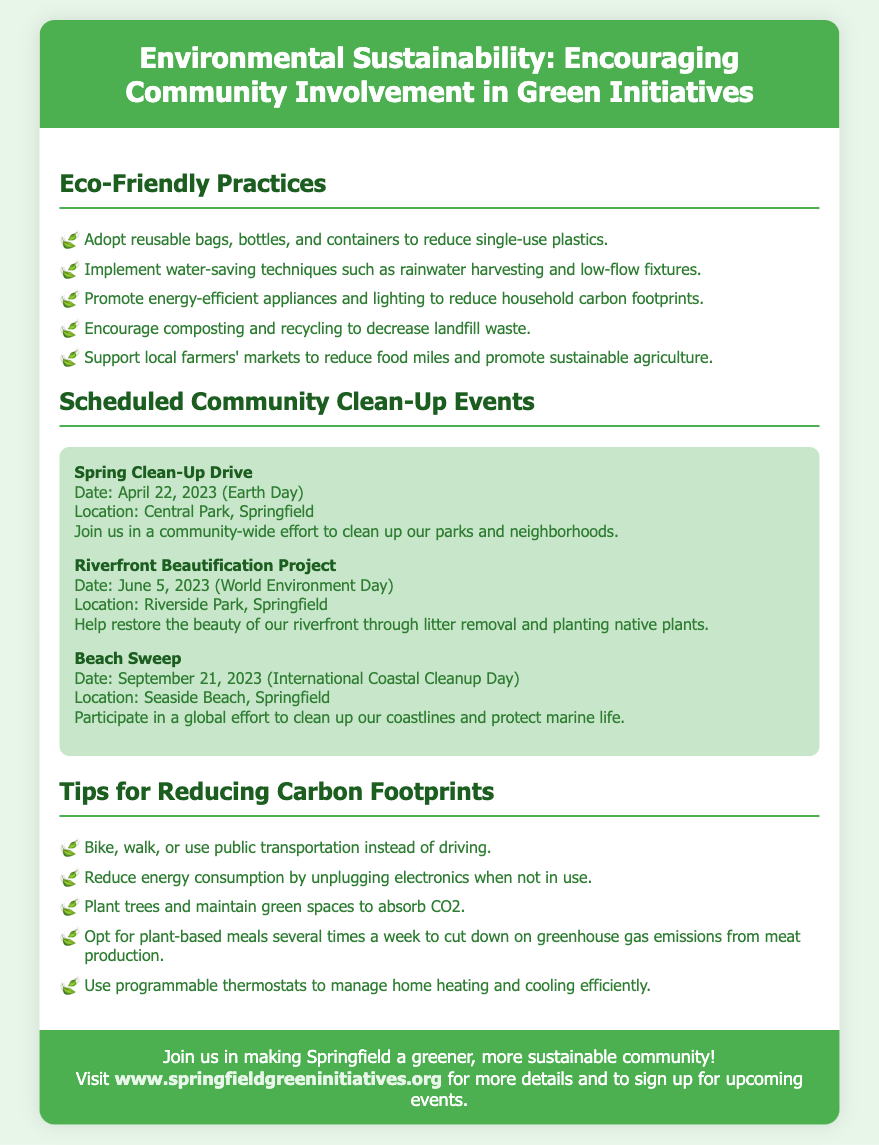What is the title of the poster? The title is prominently displayed at the top of the poster and describes the theme of the document.
Answer: Environmental Sustainability: Encouraging Community Involvement in Green Initiatives What is one eco-friendly practice mentioned in the poster? The poster lists several eco-friendly practices, each as a bullet point under the relevant section.
Answer: Adopt reusable bags, bottles, and containers to reduce single-use plastics When is the Spring Clean-Up Drive scheduled? The date for the Spring Clean-Up Drive is indicated in the events section of the poster.
Answer: April 22, 2023 Where is the Riverfront Beautification Project taking place? The location for the Riverfront Beautification Project is provided in the event details.
Answer: Riverside Park, Springfield What is one tip for reducing carbon footprints? The poster includes tips in a dedicated section, outlining various actions individuals can take.
Answer: Bike, walk, or use public transportation instead of driving How many scheduled community clean-up events are listed in the poster? The poster includes a specific number of events within the events section.
Answer: Three What type of initiatives does the poster encourage? The focus of the poster is on community involvement in environmentally friendly practices and actions.
Answer: Green Initiatives What is the call-to-action in the poster? The call-to-action section encourages readers to engage with the sustainability efforts mentioned.
Answer: Join us in making Springfield a greener, more sustainable community! 